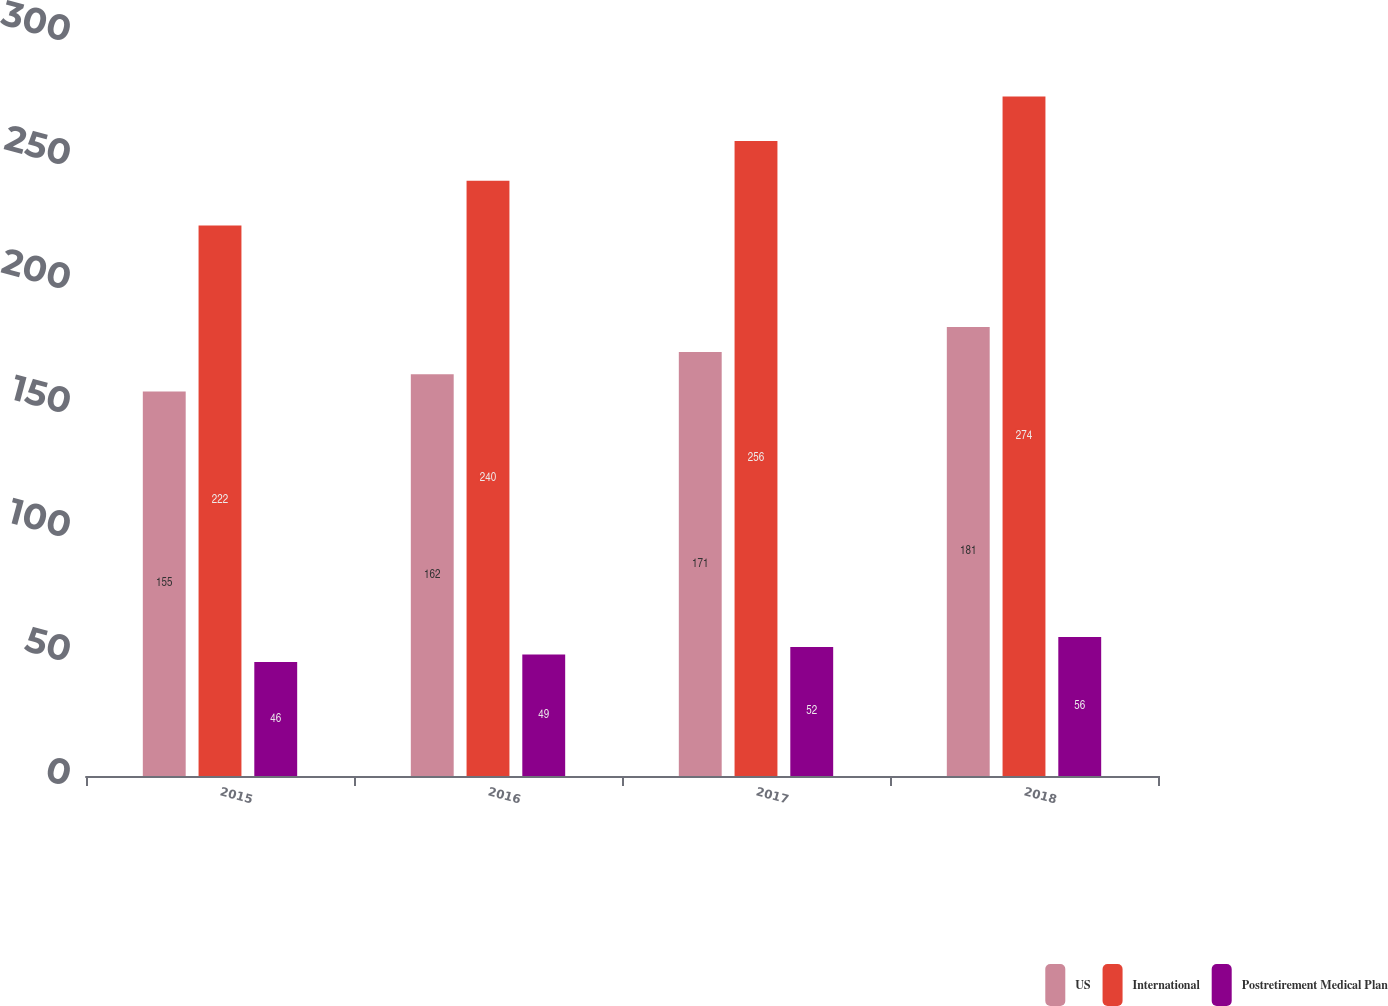<chart> <loc_0><loc_0><loc_500><loc_500><stacked_bar_chart><ecel><fcel>2015<fcel>2016<fcel>2017<fcel>2018<nl><fcel>US<fcel>155<fcel>162<fcel>171<fcel>181<nl><fcel>International<fcel>222<fcel>240<fcel>256<fcel>274<nl><fcel>Postretirement Medical Plan<fcel>46<fcel>49<fcel>52<fcel>56<nl></chart> 